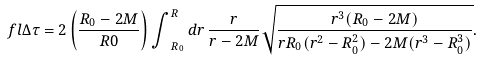<formula> <loc_0><loc_0><loc_500><loc_500>\ f l { \Delta } { \tau } = 2 \left ( \frac { R _ { 0 } - 2 M } { R 0 } \right ) { \int } _ { R _ { 0 } } ^ { R } \, d r \, \frac { r } { r - 2 M } \sqrt { \frac { r ^ { 3 } ( R _ { 0 } - 2 M ) } { r R _ { 0 } ( r ^ { 2 } - R _ { 0 } ^ { 2 } ) - 2 M ( r ^ { 3 } - R _ { 0 } ^ { 3 } ) } } .</formula> 